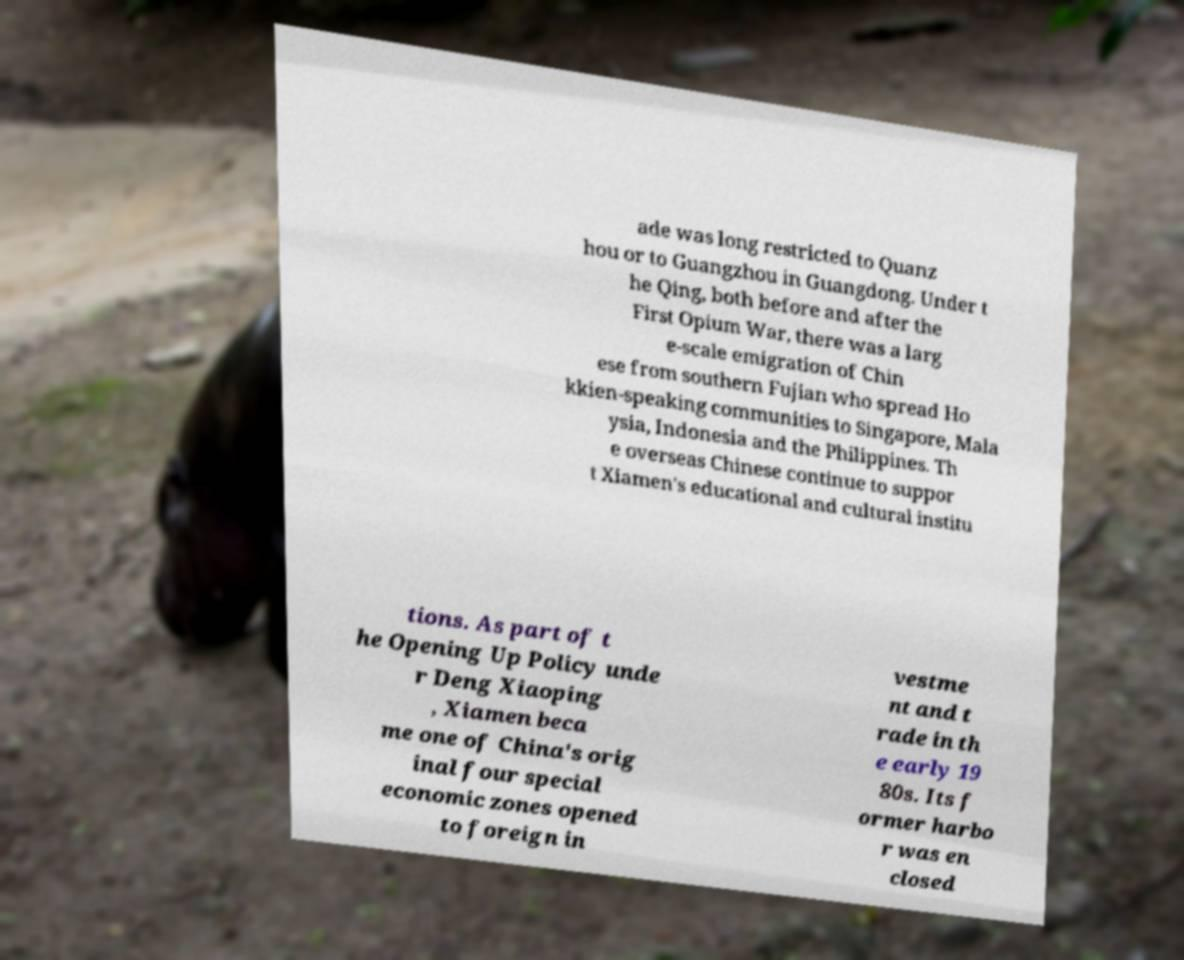Can you read and provide the text displayed in the image?This photo seems to have some interesting text. Can you extract and type it out for me? ade was long restricted to Quanz hou or to Guangzhou in Guangdong. Under t he Qing, both before and after the First Opium War, there was a larg e-scale emigration of Chin ese from southern Fujian who spread Ho kkien-speaking communities to Singapore, Mala ysia, Indonesia and the Philippines. Th e overseas Chinese continue to suppor t Xiamen's educational and cultural institu tions. As part of t he Opening Up Policy unde r Deng Xiaoping , Xiamen beca me one of China's orig inal four special economic zones opened to foreign in vestme nt and t rade in th e early 19 80s. Its f ormer harbo r was en closed 